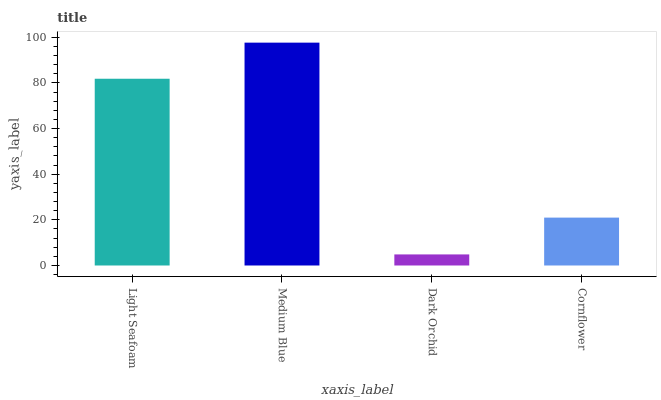Is Medium Blue the minimum?
Answer yes or no. No. Is Dark Orchid the maximum?
Answer yes or no. No. Is Medium Blue greater than Dark Orchid?
Answer yes or no. Yes. Is Dark Orchid less than Medium Blue?
Answer yes or no. Yes. Is Dark Orchid greater than Medium Blue?
Answer yes or no. No. Is Medium Blue less than Dark Orchid?
Answer yes or no. No. Is Light Seafoam the high median?
Answer yes or no. Yes. Is Cornflower the low median?
Answer yes or no. Yes. Is Dark Orchid the high median?
Answer yes or no. No. Is Medium Blue the low median?
Answer yes or no. No. 